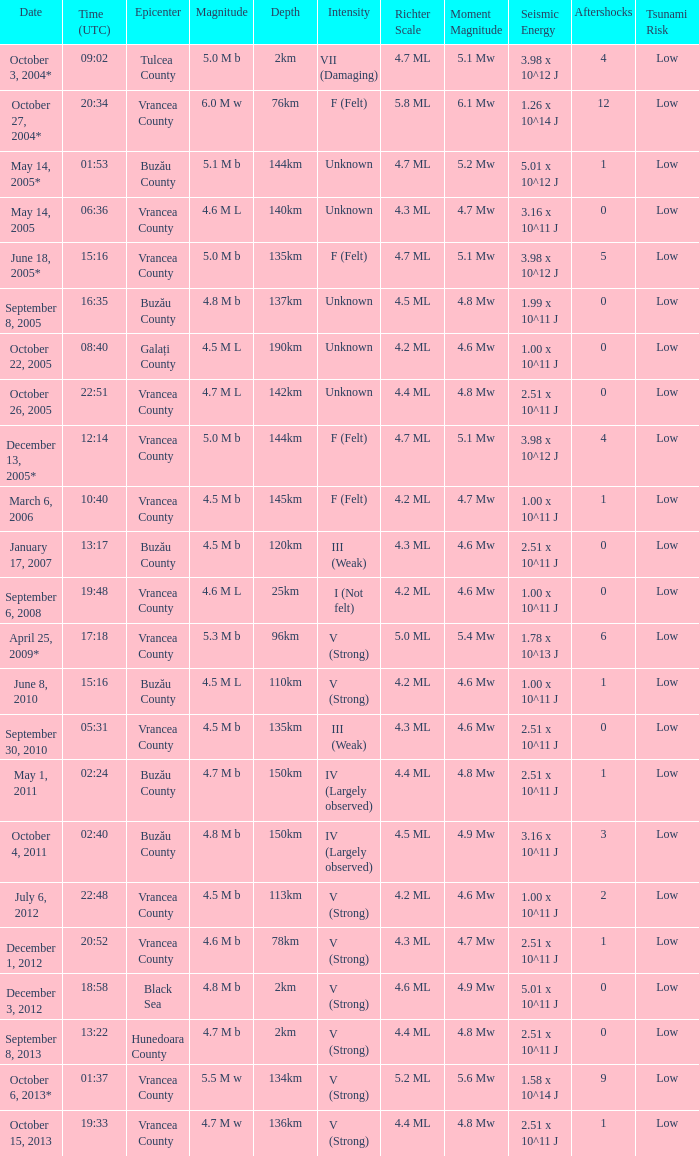What is the magnitude with epicenter at Vrancea County, unknown intensity and which happened at 06:36? 4.6 M L. 